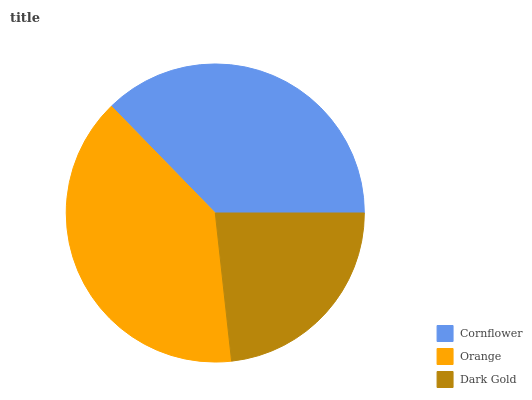Is Dark Gold the minimum?
Answer yes or no. Yes. Is Orange the maximum?
Answer yes or no. Yes. Is Orange the minimum?
Answer yes or no. No. Is Dark Gold the maximum?
Answer yes or no. No. Is Orange greater than Dark Gold?
Answer yes or no. Yes. Is Dark Gold less than Orange?
Answer yes or no. Yes. Is Dark Gold greater than Orange?
Answer yes or no. No. Is Orange less than Dark Gold?
Answer yes or no. No. Is Cornflower the high median?
Answer yes or no. Yes. Is Cornflower the low median?
Answer yes or no. Yes. Is Orange the high median?
Answer yes or no. No. Is Orange the low median?
Answer yes or no. No. 